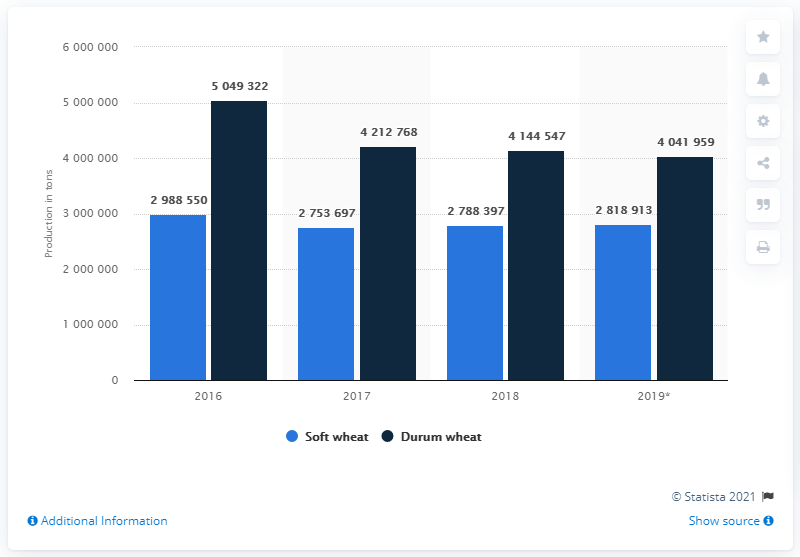Point out several critical features in this image. In 2018, durum wheat was the type of wheat production that was highest. The difference between the highest value of durum wheat and the lowest value of soft wheat over the years is approximately 229,562,500. 